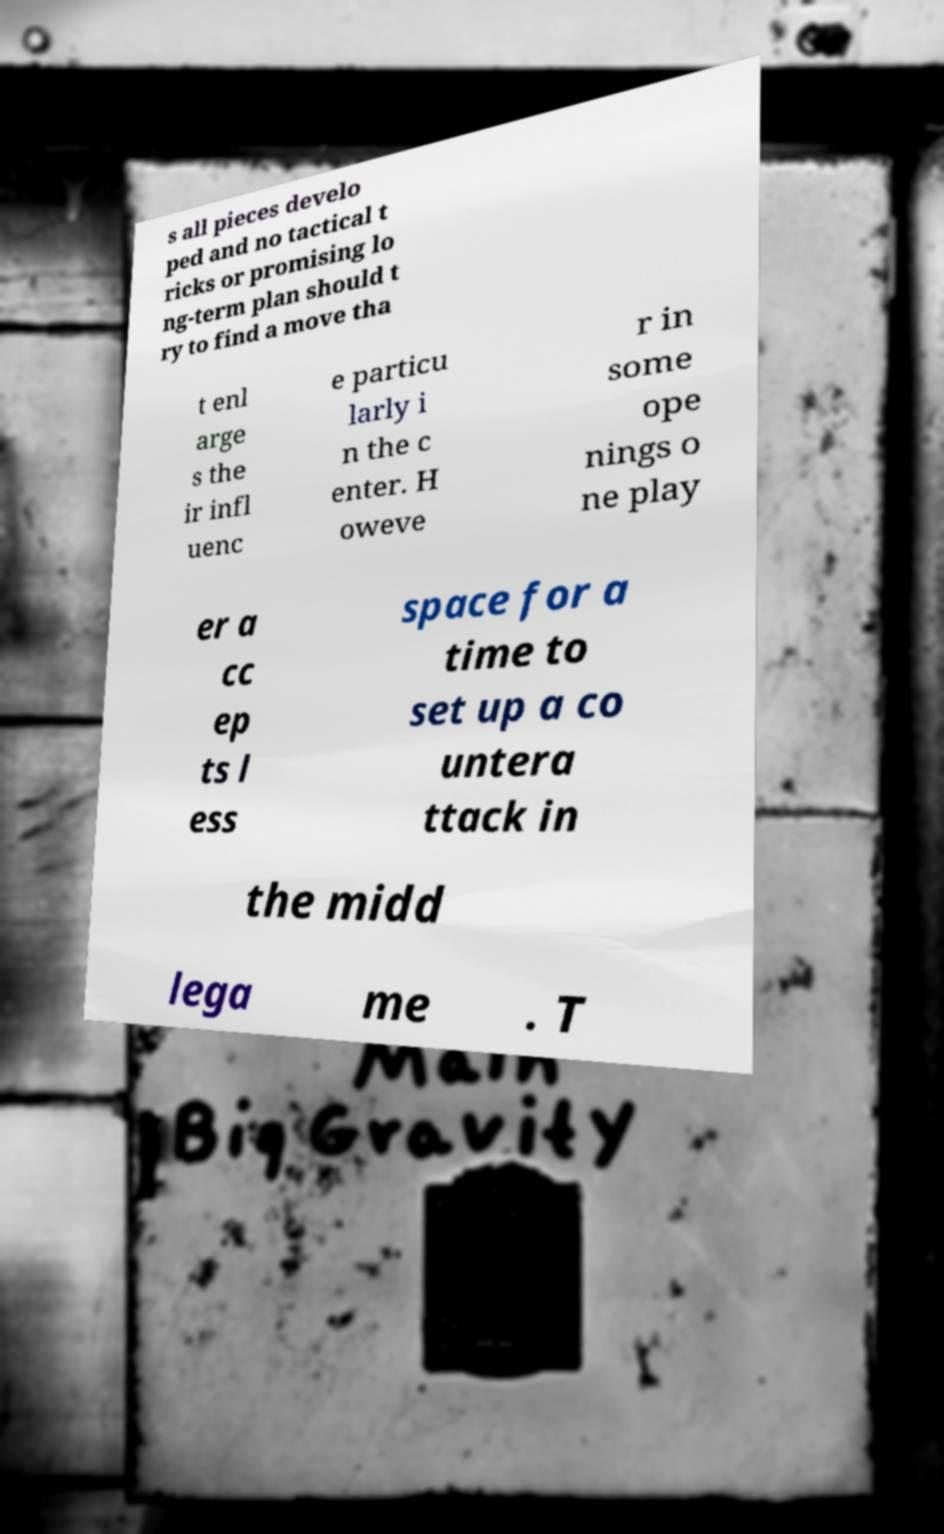Can you read and provide the text displayed in the image?This photo seems to have some interesting text. Can you extract and type it out for me? s all pieces develo ped and no tactical t ricks or promising lo ng-term plan should t ry to find a move tha t enl arge s the ir infl uenc e particu larly i n the c enter. H oweve r in some ope nings o ne play er a cc ep ts l ess space for a time to set up a co untera ttack in the midd lega me . T 